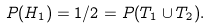<formula> <loc_0><loc_0><loc_500><loc_500>P ( H _ { 1 } ) = 1 / 2 = P ( T _ { 1 } \cup T _ { 2 } ) .</formula> 